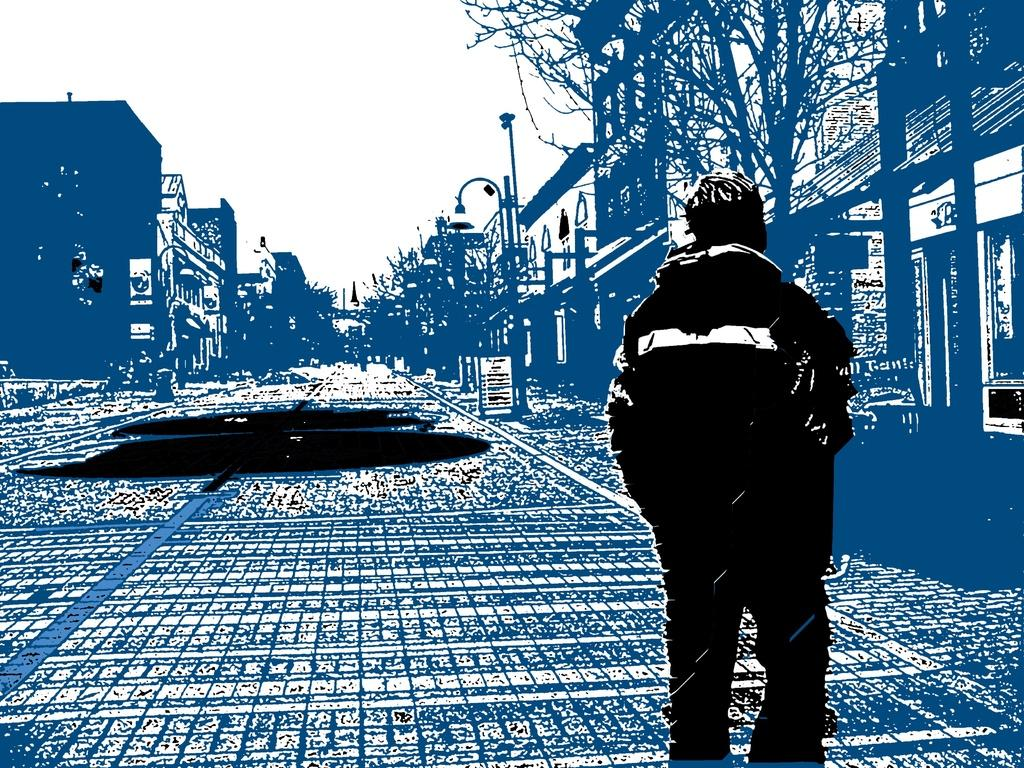What type of image is shown in the picture? The image is a graphics image. Can you describe the main subject in the image? There is a person in the image. What structures are present on the sides of the image? There are buildings on the sides of the image. What type of vegetation can be seen in the image? There are trees in the image. What is the purpose of the object in the middle of the image? There is a light pole in the image, which is likely used for illumination. What can be seen in the background of the image? The sky is visible in the background of the image. What type of cracker is being eaten by the person in the image? There is no cracker present in the image, and the person's actions are not described. 